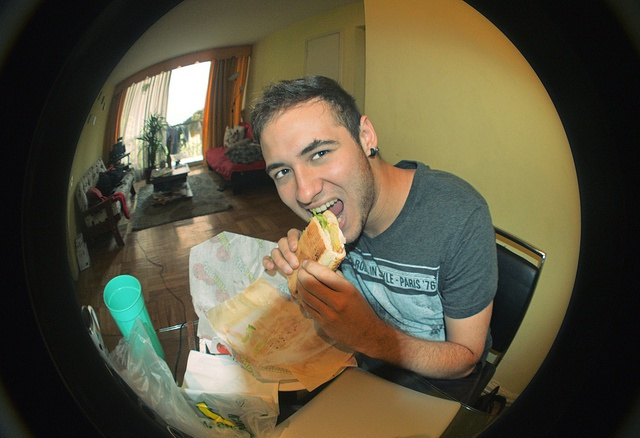Describe the objects in this image and their specific colors. I can see people in black, gray, and tan tones, chair in black, gray, and olive tones, couch in black, gray, and maroon tones, couch in black, maroon, and gray tones, and cup in black, turquoise, and teal tones in this image. 